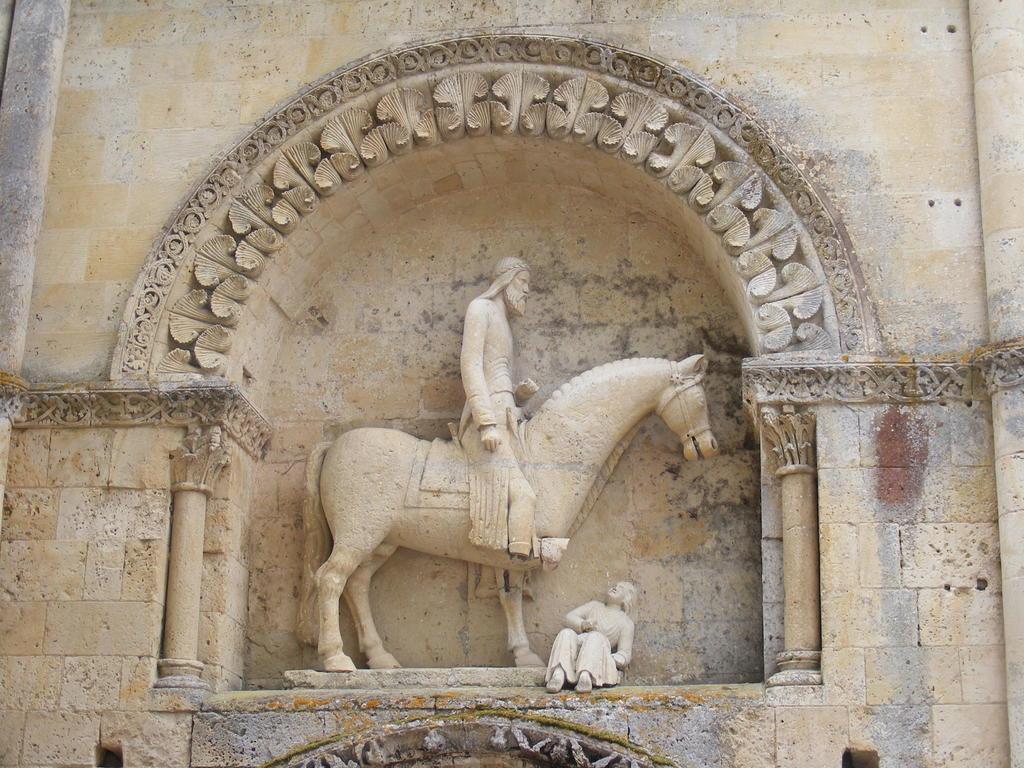Please provide a concise description of this image. In this image I can see a wall which is cream and white in color. I can see a statue of a person sitting on the horse and another person sitting which are cream in color to the wall. 